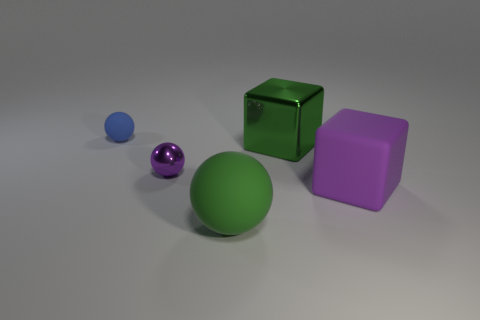Add 2 purple matte blocks. How many objects exist? 7 Subtract all cubes. How many objects are left? 3 Subtract 0 yellow spheres. How many objects are left? 5 Subtract all big green balls. Subtract all tiny rubber objects. How many objects are left? 3 Add 3 big green rubber balls. How many big green rubber balls are left? 4 Add 3 green cylinders. How many green cylinders exist? 3 